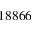Convert formula to latex. <formula><loc_0><loc_0><loc_500><loc_500>1 8 8 6 6</formula> 